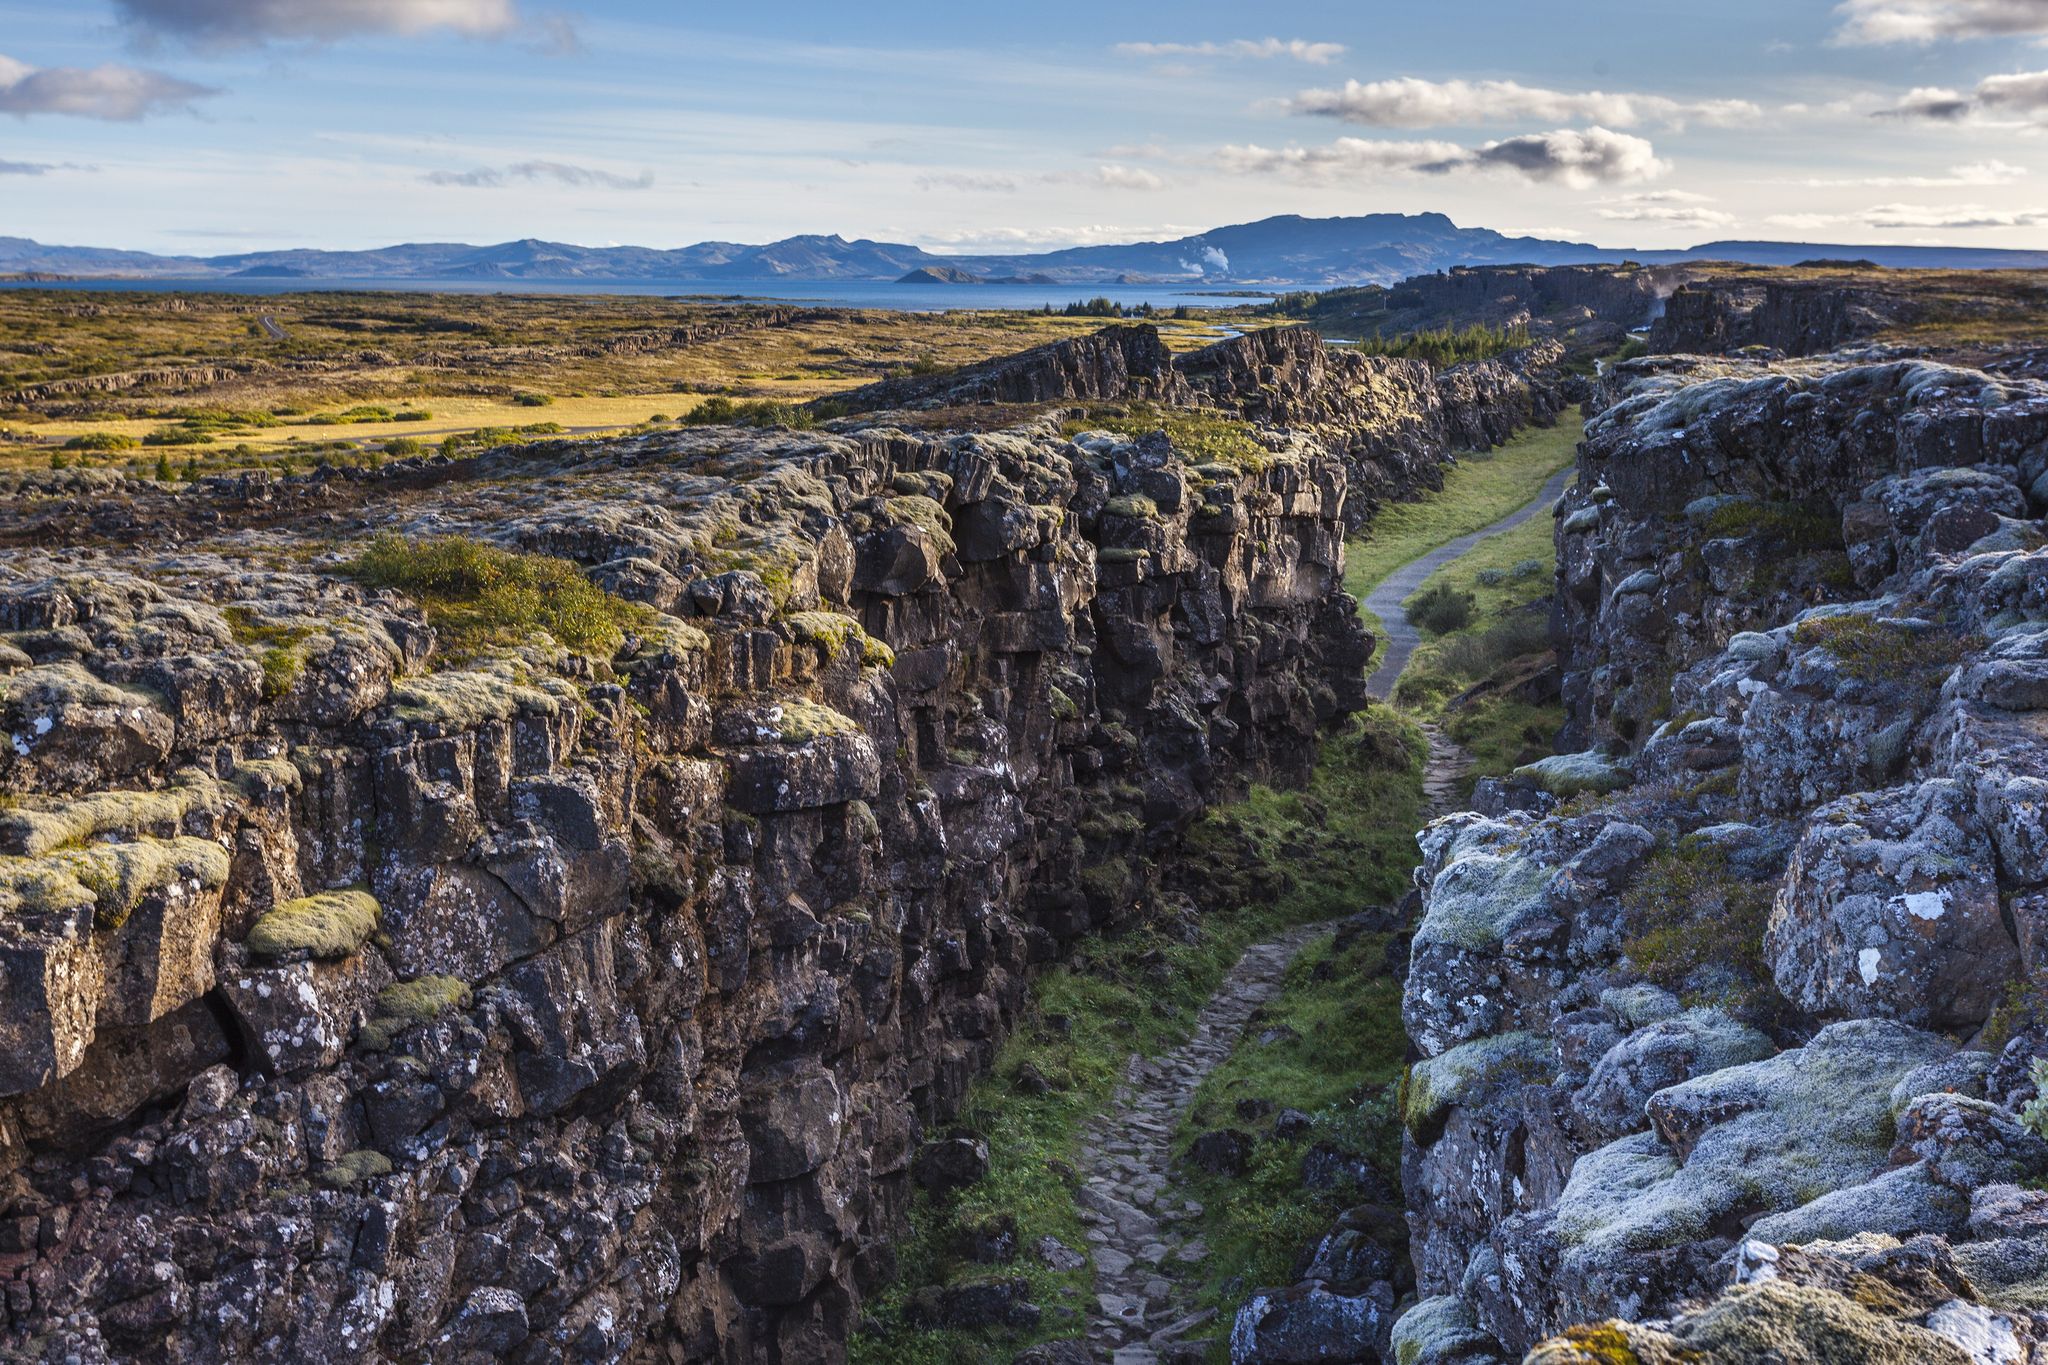What is this photo about? This captivating image showcases the natural splendor of Þingvellir National Park in Iceland. From an elevated viewpoint, one can see a dramatic gorge cutting through the landscape, flanked by rugged cliffs covered in lush moss and lichen. A winding path travels the length of the gorge, inviting exploration. In the distance, a tranquil lake mirrors the sky, and far-off mountains add depth to the scene. The dominant colors are earthy greens and browns, with pops of blue from the sky and water, beautifully illustrating the park's unique geological features and serene beauty. 